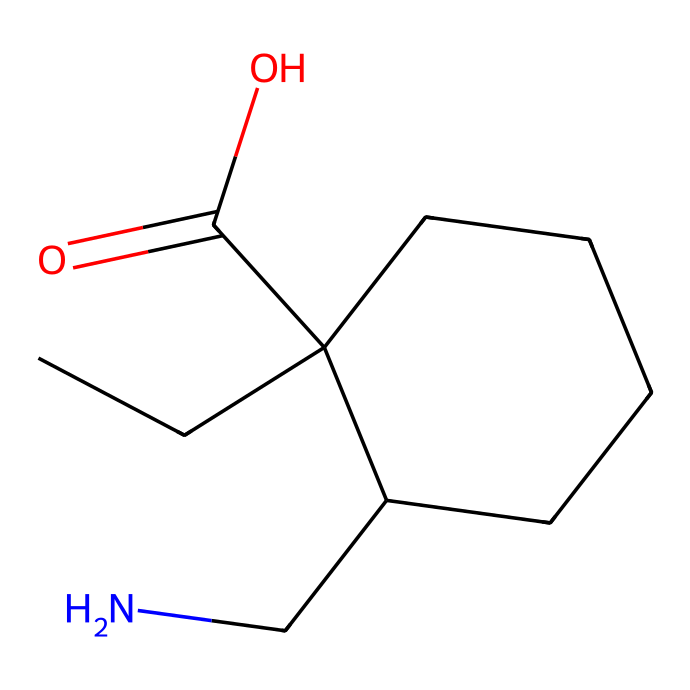What is the molecular formula of gabapentin? To determine the molecular formula from the SMILES representation, count the number of each type of atom present in the structure. The structure shows 10 carbons (C), 17 hydrogens (H), 1 nitrogen (N), and 2 oxygens (O), leading to the formula C10H17N2O2.
Answer: C10H17N2O2 How many rings are present in gabapentin's structure? In the provided SMILES representation, there is a cyclic component denoted by "C1" and "CC1", indicating the presence of a ring. There is only one complete ring in the structure.
Answer: 1 What type of functional group is present in gabapentin? Analyzing the structure indicates the presence of a carboxylic acid (-COOH) group, which is characterized by the "C(=O)O" part of the SMILES. This specific arrangement confirms the presence of this functional group.
Answer: carboxylic acid What elements are found in gabapentin? The SMILES representation includes the letters C, H, N, and O, indicating the elements carbon, hydrogen, nitrogen, and oxygen, respectively. It's essential to identify each letter to determine the elements.
Answer: carbon, hydrogen, nitrogen, oxygen How many chiral centers are in the gabapentin molecule? By examining the structure, a chiral center is identified at the carbon atom attached to the nitrogen and the two different carbon substituents. Identifying chiral centers involves checking for carbon atoms bonded to four different groups. There is one such chiral center in gabapentin.
Answer: 1 What is the major type of bond characterizing gabapentin? The chemical structure shows predominantly single covalent bonds, as indicated by the connections between carbon atoms and other atoms. The absence of any double or triple bonds in the structure further supports that this compound is characterized by single bonds.
Answer: single bonds What is the primary use of gabapentin? Gabapentin is primarily used as an anticonvulsant for treating neuropathic pain, as indicated by its classification and therapeutic application in medical contexts. Knowledge of the drug's purpose is essential for understanding its role in pharmacology.
Answer: anticonvulsant 